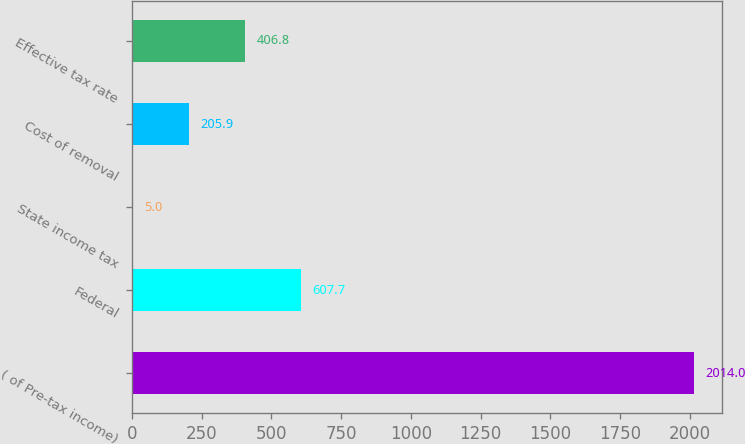Convert chart. <chart><loc_0><loc_0><loc_500><loc_500><bar_chart><fcel>( of Pre-tax income)<fcel>Federal<fcel>State income tax<fcel>Cost of removal<fcel>Effective tax rate<nl><fcel>2014<fcel>607.7<fcel>5<fcel>205.9<fcel>406.8<nl></chart> 